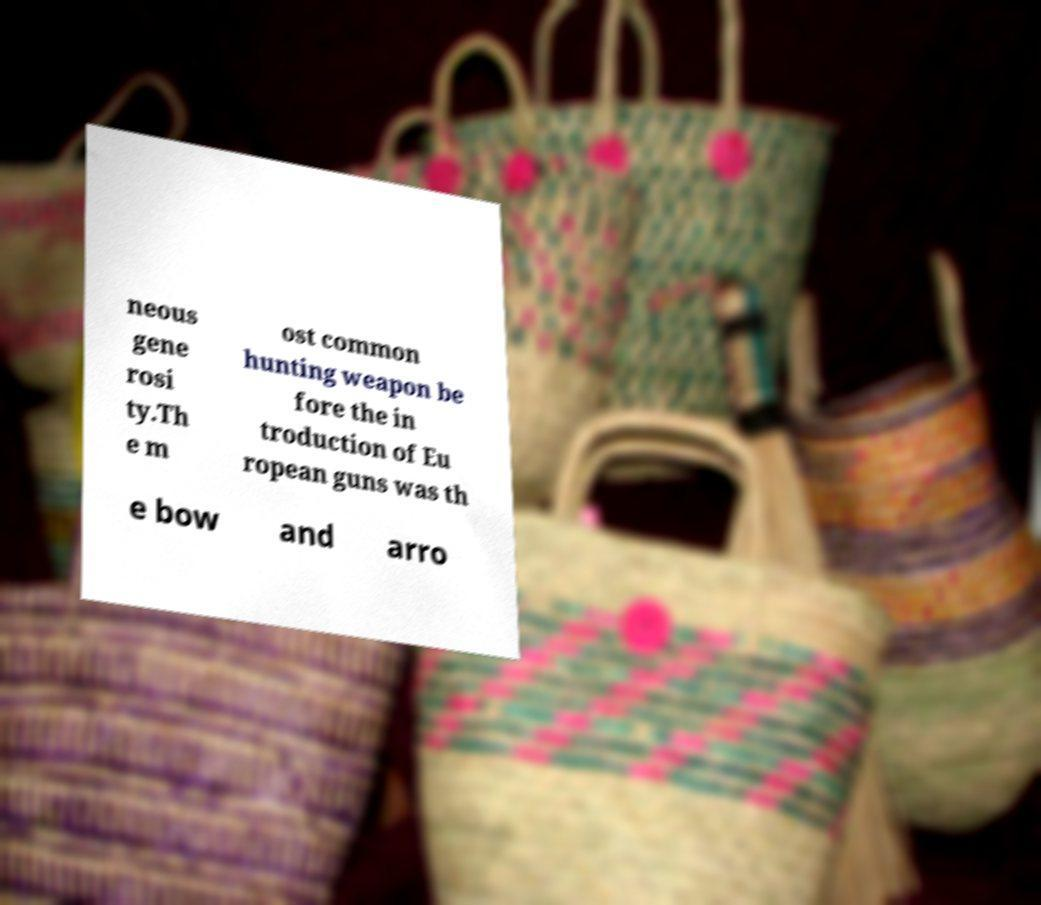Can you read and provide the text displayed in the image?This photo seems to have some interesting text. Can you extract and type it out for me? neous gene rosi ty.Th e m ost common hunting weapon be fore the in troduction of Eu ropean guns was th e bow and arro 